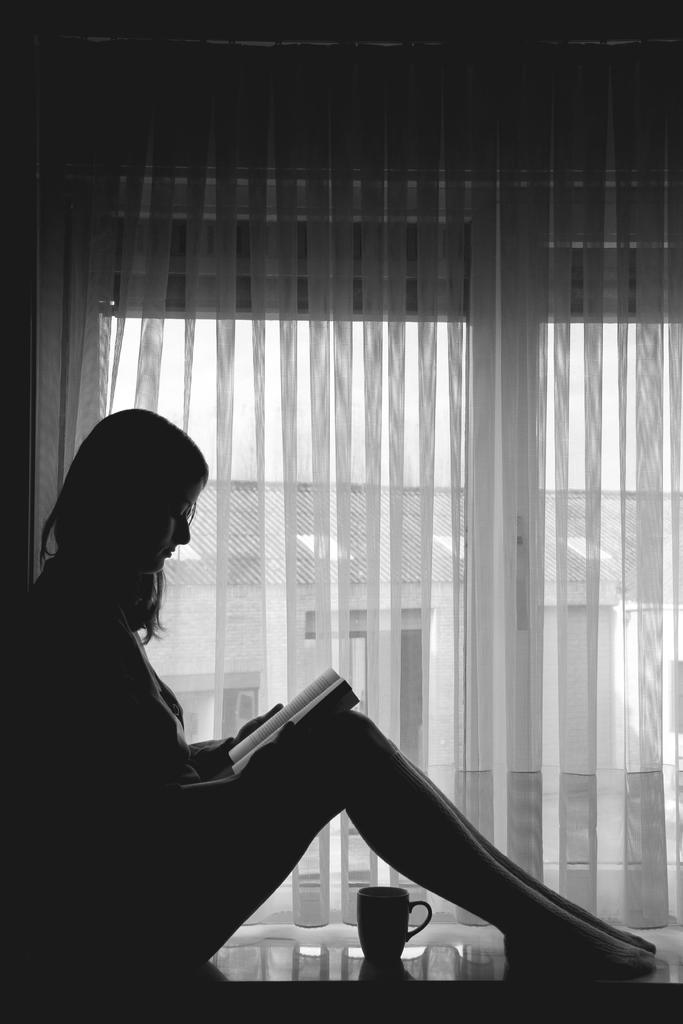What is the woman in the image doing? The woman is sitting in the image and holding a book. What object is on a platform in the image? There is a cup on a platform in the image. What can be seen through the curtains in the image? A building and the sky are visible through the curtains in the image. What type of window treatment is present in the image? Curtains are visible in the image. What type of plants can be seen growing out of the woman's tail in the image? There is no tail or plants present on the woman in the image. 